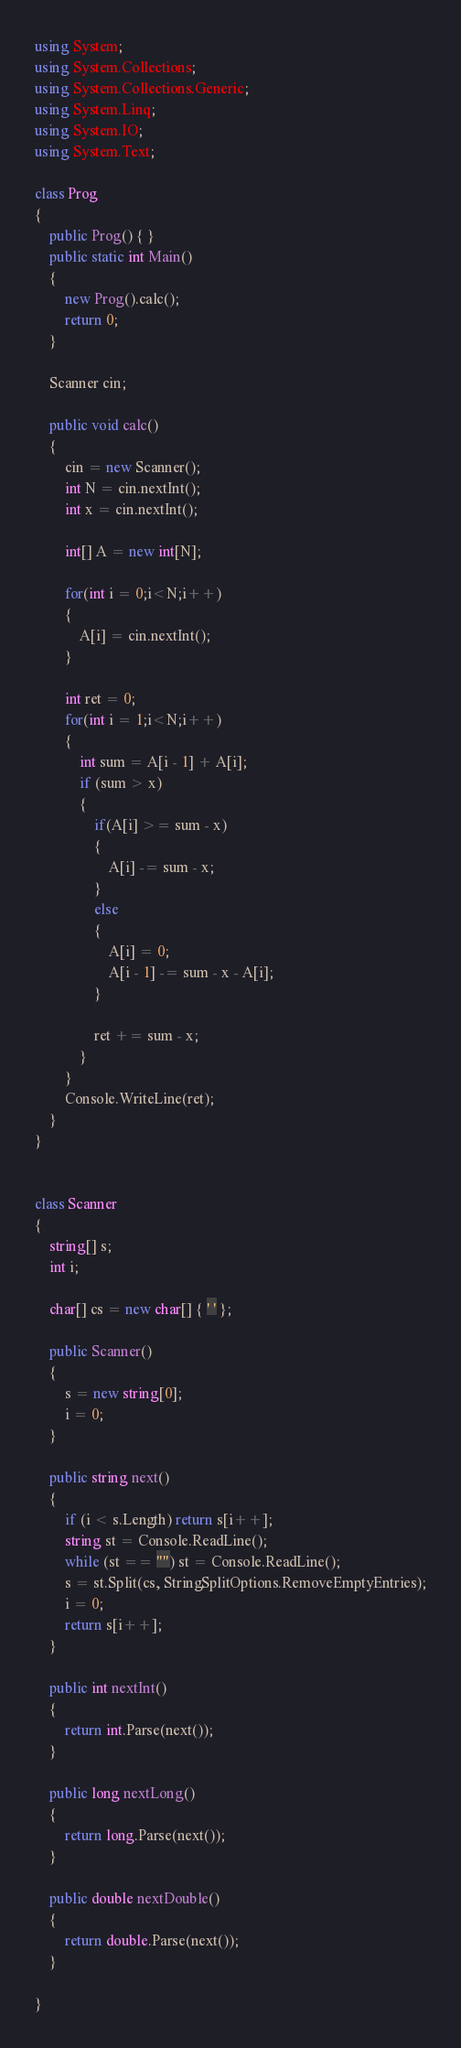Convert code to text. <code><loc_0><loc_0><loc_500><loc_500><_C#_>using System;
using System.Collections;
using System.Collections.Generic;
using System.Linq;
using System.IO;
using System.Text;

class Prog
{
    public Prog() { }
    public static int Main()
    {
        new Prog().calc();
        return 0;
    }

    Scanner cin;

    public void calc()
    {
        cin = new Scanner();
        int N = cin.nextInt();
        int x = cin.nextInt();

        int[] A = new int[N];

        for(int i = 0;i<N;i++)
        {
            A[i] = cin.nextInt();
        }

        int ret = 0;
        for(int i = 1;i<N;i++)
        {
            int sum = A[i - 1] + A[i];
            if (sum > x)
            {
                if(A[i] >= sum - x)
                {
                    A[i] -= sum - x;
                }
                else
                {
                    A[i] = 0;
                    A[i - 1] -= sum - x - A[i];
                }

                ret += sum - x;
            }
        }
        Console.WriteLine(ret);
    }
}


class Scanner
{
    string[] s;
    int i;

    char[] cs = new char[] { ' ' };

    public Scanner()
    {
        s = new string[0];
        i = 0;
    }

    public string next()
    {
        if (i < s.Length) return s[i++];
        string st = Console.ReadLine();
        while (st == "") st = Console.ReadLine();
        s = st.Split(cs, StringSplitOptions.RemoveEmptyEntries);
        i = 0;
        return s[i++];
    }

    public int nextInt()
    {
        return int.Parse(next());
    }

    public long nextLong()
    {
        return long.Parse(next());
    }

    public double nextDouble()
    {
        return double.Parse(next());
    }

}</code> 